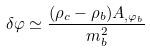Convert formula to latex. <formula><loc_0><loc_0><loc_500><loc_500>\delta \varphi \simeq \frac { ( \rho _ { c } - \rho _ { b } ) A _ { , \varphi _ { b } } } { m _ { b } ^ { 2 } }</formula> 